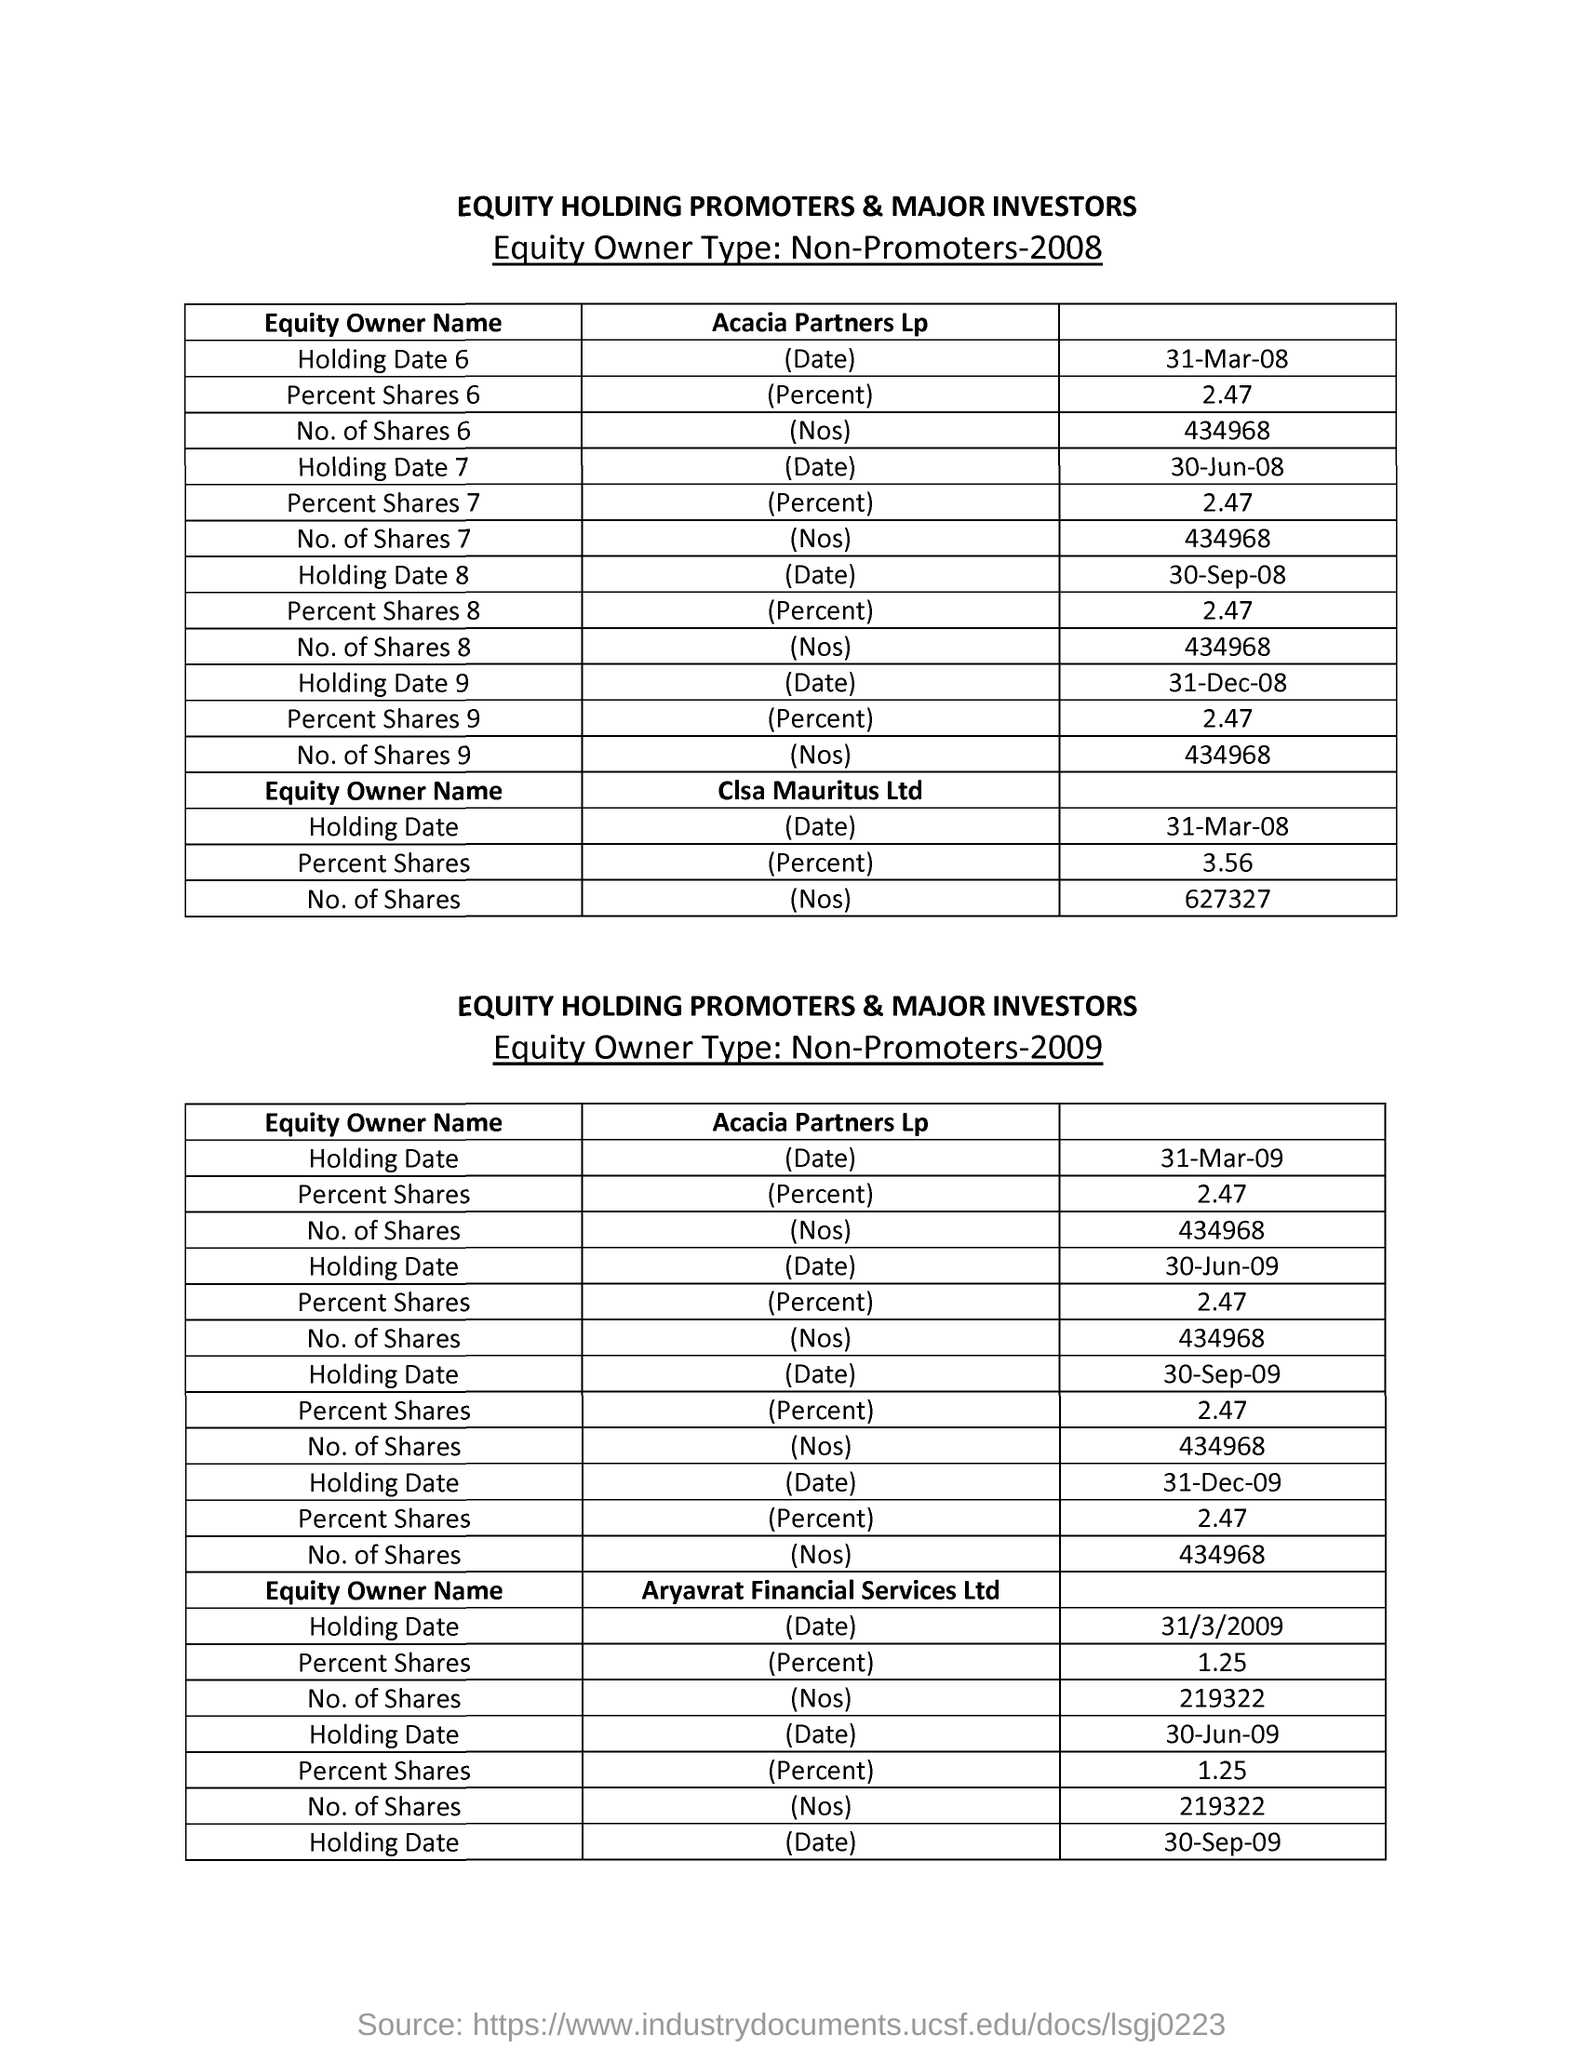Draw attention to some important aspects in this diagram. The Holding Date 6 for Acacia Partners Lp in the year 2008 was March 31, 2008. The percent share for Clsa Mauritus Ltd in the year 2008 was 3.56%. The holding date for Closa Mauritus Ltd in the year 2008 was March 31st. In the year 2008, the number of shares for Clsa Maauritius Ltd was 627,327. The Percent Shares 6 for Acacia Partners Lp in 2008 was 2.47. 